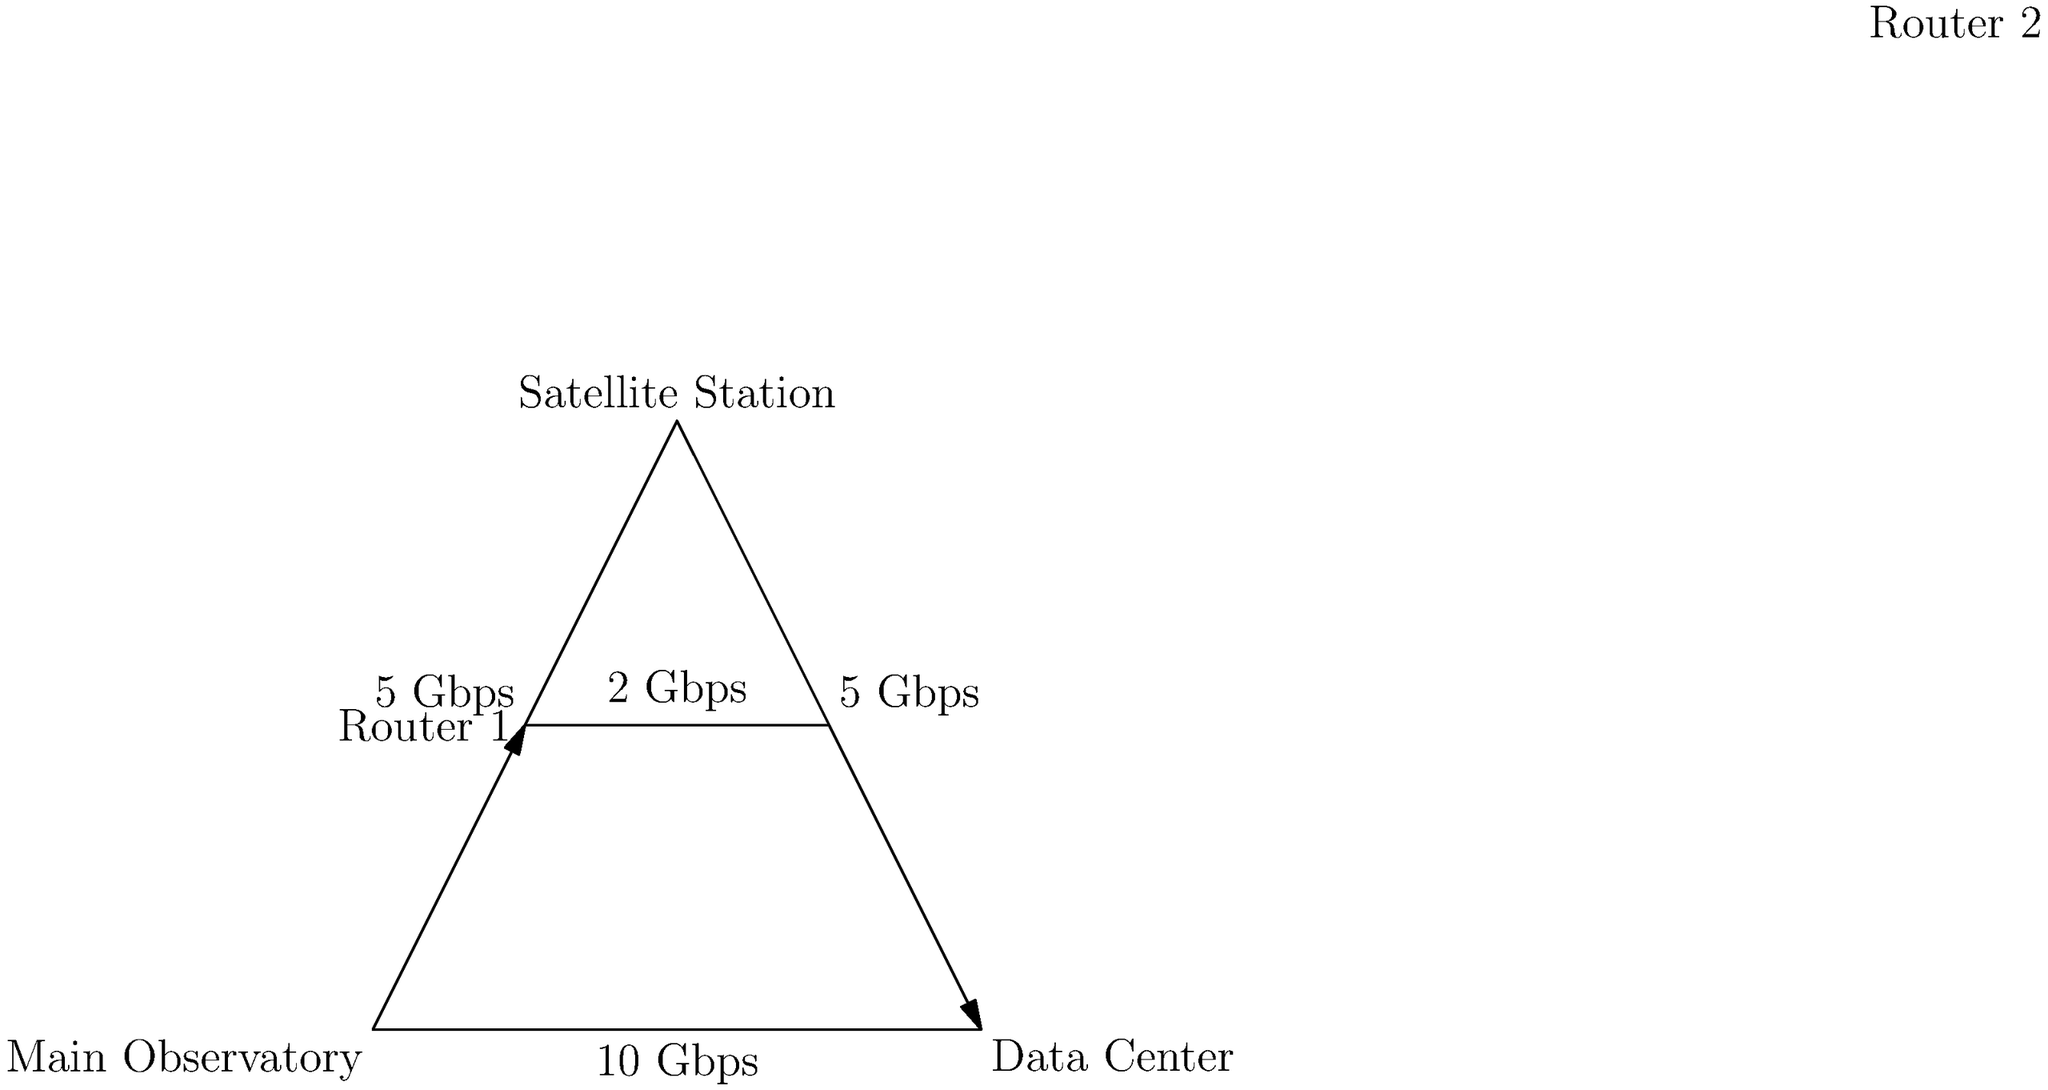Given the network topology shown in the diagram, what is the minimum bandwidth required between Router 1 and Router 2 to ensure efficient transfer of a 100 TB astronomical dataset from the Main Observatory to the Data Center within 24 hours, assuming constant data flow and no network overhead? To solve this problem, we need to follow these steps:

1. Identify the data transfer requirements:
   - Total data to transfer: 100 TB
   - Time constraint: 24 hours

2. Convert units for consistency:
   - 100 TB = 100,000 GB
   - 24 hours = 86,400 seconds

3. Calculate the required data transfer rate:
   $$ \text{Transfer Rate} = \frac{\text{Data Size}}{\text{Time}} $$
   $$ \text{Transfer Rate} = \frac{100,000 \text{ GB}}{86,400 \text{ s}} \approx 1.157 \text{ GB/s} $$

4. Convert GB/s to Gbps (Gigabits per second):
   $$ 1.157 \text{ GB/s} \times 8 \text{ bits/byte} \approx 9.26 \text{ Gbps} $$

5. Consider the network topology:
   - The data must pass through Router 1 and Router 2
   - The current bandwidth between routers is 2 Gbps

6. Determine the minimum required bandwidth:
   - The calculated 9.26 Gbps is higher than the current 2 Gbps
   - Therefore, the minimum required bandwidth is 9.26 Gbps, rounded up to 10 Gbps for practical implementation

Thus, the minimum bandwidth required between Router 1 and Router 2 should be upgraded to 10 Gbps to ensure efficient transfer of the astronomical dataset within the given time frame.
Answer: 10 Gbps 